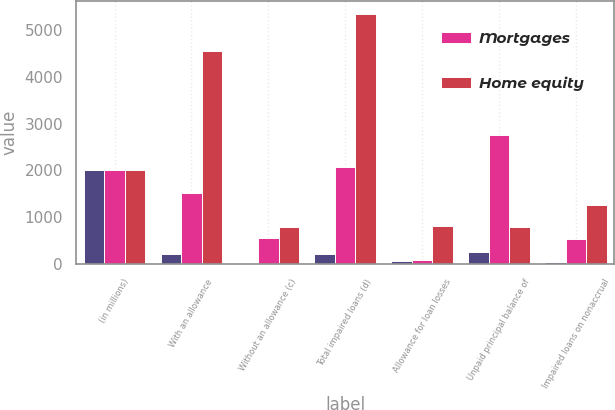Convert chart to OTSL. <chart><loc_0><loc_0><loc_500><loc_500><stacked_bar_chart><ecel><fcel>(in millions)<fcel>With an allowance<fcel>Without an allowance (c)<fcel>Total impaired loans (d)<fcel>Allowance for loan losses<fcel>Unpaid principal balance of<fcel>Impaired loans on nonaccrual<nl><fcel>nan<fcel>2010<fcel>211<fcel>15<fcel>226<fcel>77<fcel>265<fcel>38<nl><fcel>Mortgages<fcel>2010<fcel>1525<fcel>559<fcel>2084<fcel>97<fcel>2751<fcel>534<nl><fcel>Home equity<fcel>2010<fcel>4557<fcel>787<fcel>5344<fcel>811<fcel>799<fcel>1267<nl></chart> 